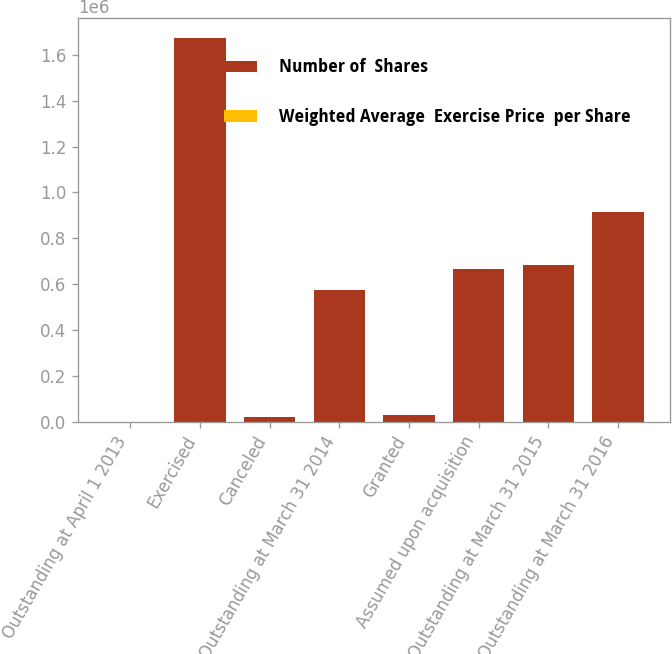<chart> <loc_0><loc_0><loc_500><loc_500><stacked_bar_chart><ecel><fcel>Outstanding at April 1 2013<fcel>Exercised<fcel>Canceled<fcel>Outstanding at March 31 2014<fcel>Granted<fcel>Assumed upon acquisition<fcel>Outstanding at March 31 2015<fcel>Outstanding at March 31 2016<nl><fcel>Number of  Shares<fcel>46.66<fcel>1.67566e+06<fcel>20529<fcel>573611<fcel>27654<fcel>666586<fcel>684299<fcel>913508<nl><fcel>Weighted Average  Exercise Price  per Share<fcel>25.58<fcel>25.91<fcel>22.78<fcel>24.75<fcel>46.66<fcel>29.33<fcel>28.41<fcel>33<nl></chart> 